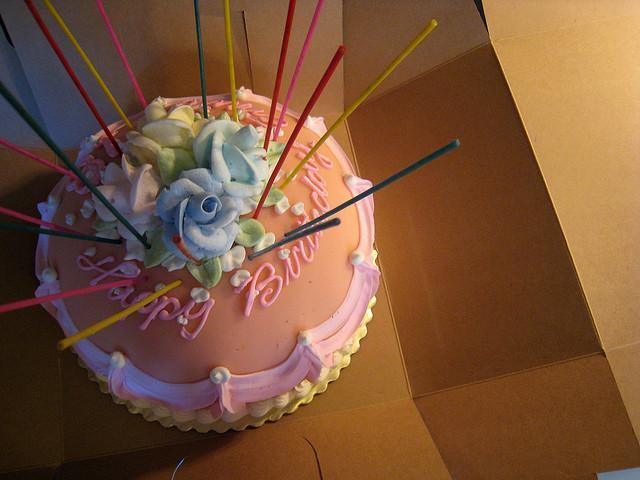How many dogs are there?
Give a very brief answer. 0. 